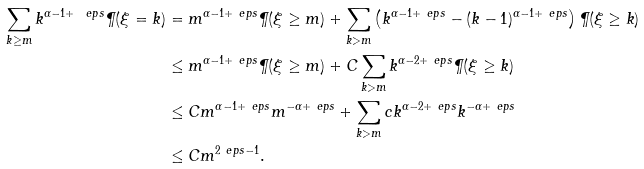<formula> <loc_0><loc_0><loc_500><loc_500>\sum _ { k \geq m } k ^ { \alpha - 1 + \ e p s } \P ( \xi = k ) & = m ^ { \alpha - 1 + \ e p s } \P ( \xi \geq m ) + \sum _ { k > m } \left ( k ^ { \alpha - 1 + \ e p s } - ( k - 1 ) ^ { \alpha - 1 + \ e p s } \right ) \P ( \xi \geq k ) \\ & \leq m ^ { \alpha - 1 + \ e p s } \P ( \xi \geq m ) + C \sum _ { k > m } k ^ { \alpha - 2 + \ e p s } \P ( \xi \geq k ) \\ & \leq C m ^ { \alpha - 1 + \ e p s } m ^ { - \alpha + \ e p s } + \sum _ { k > m } c k ^ { \alpha - 2 + \ e p s } k ^ { - \alpha + \ e p s } \\ & \leq C m ^ { 2 \ e p s - 1 } .</formula> 